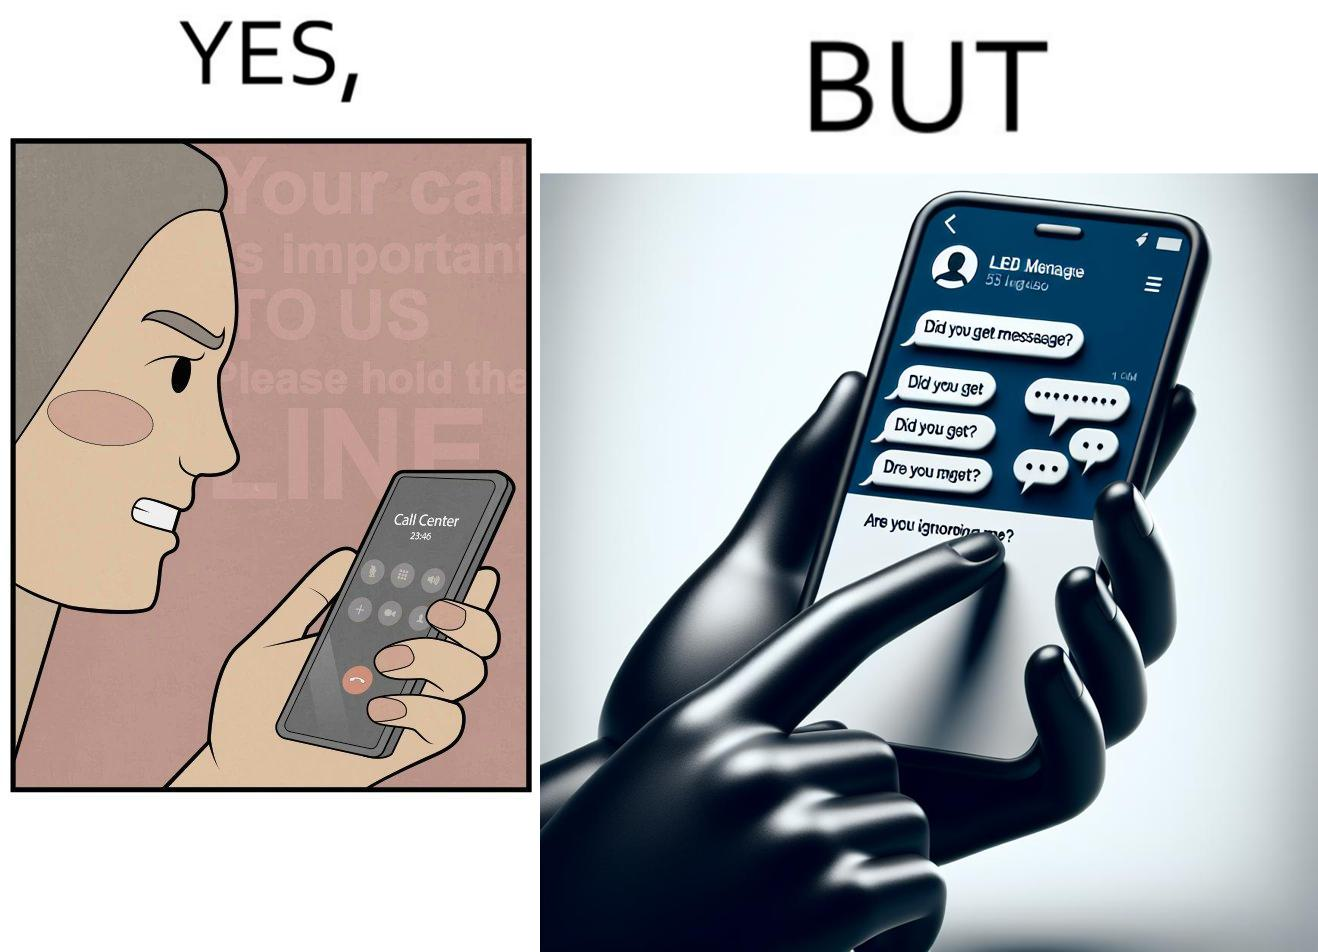Describe the content of this image. The image is ironical because while the woman is annoyed by the unresponsiveness of the call center, she herself is being unresponsive to many people in the chat. 